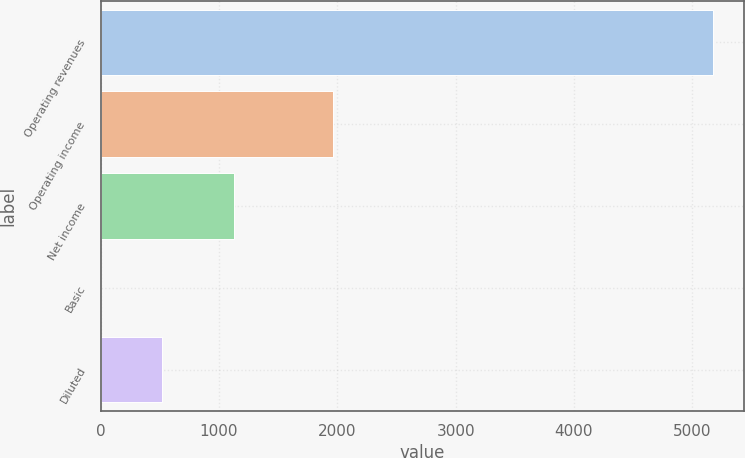<chart> <loc_0><loc_0><loc_500><loc_500><bar_chart><fcel>Operating revenues<fcel>Operating income<fcel>Net income<fcel>Basic<fcel>Diluted<nl><fcel>5174<fcel>1960<fcel>1131<fcel>1.36<fcel>518.62<nl></chart> 